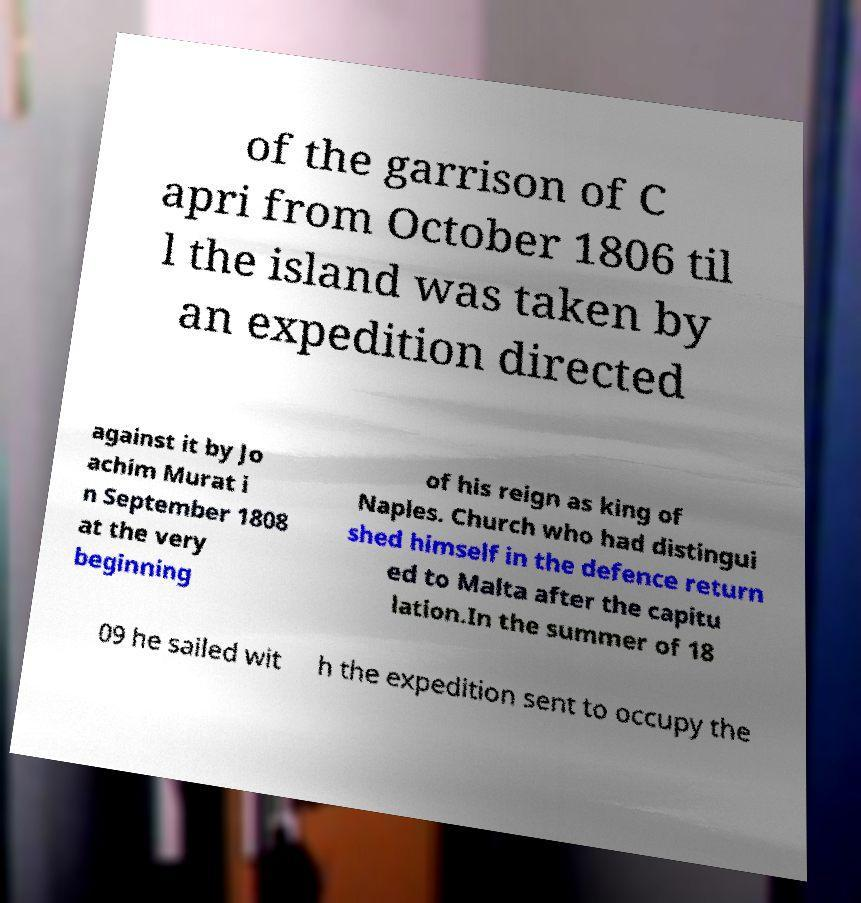I need the written content from this picture converted into text. Can you do that? of the garrison of C apri from October 1806 til l the island was taken by an expedition directed against it by Jo achim Murat i n September 1808 at the very beginning of his reign as king of Naples. Church who had distingui shed himself in the defence return ed to Malta after the capitu lation.In the summer of 18 09 he sailed wit h the expedition sent to occupy the 